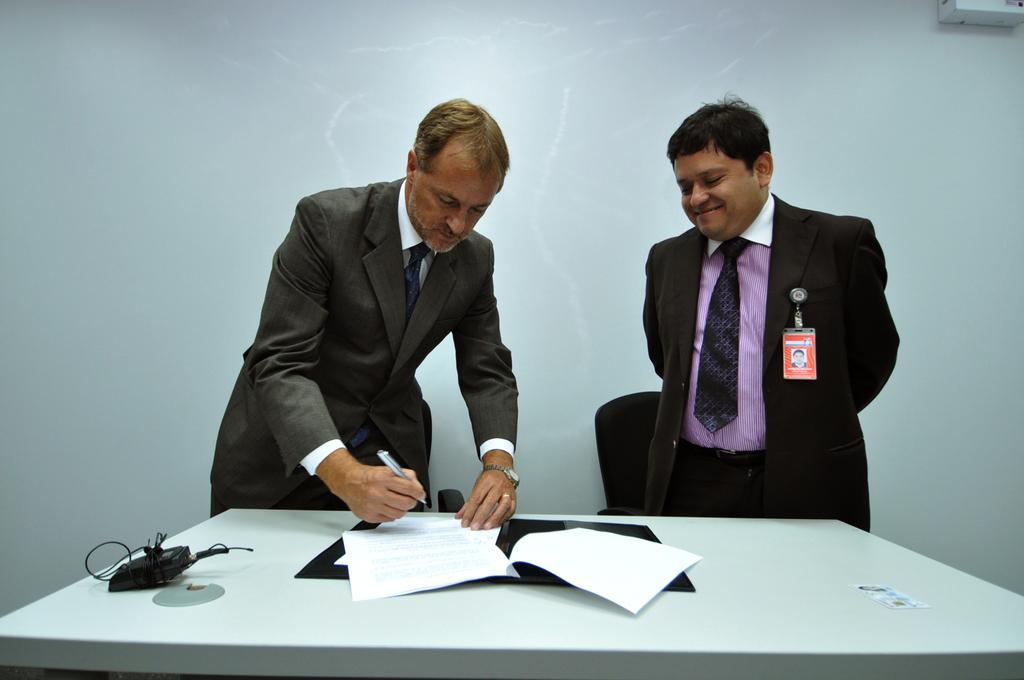In one or two sentences, can you explain what this image depicts? In this picture I can see there is a man standing, he is wearing a blazer, shirt and he is holding a pen and papers which are placed on the table in a file and there is another man next to him, he is wearing a blazer, ID card and smiling. In the backdrop, there are chairs and there is a wall. 